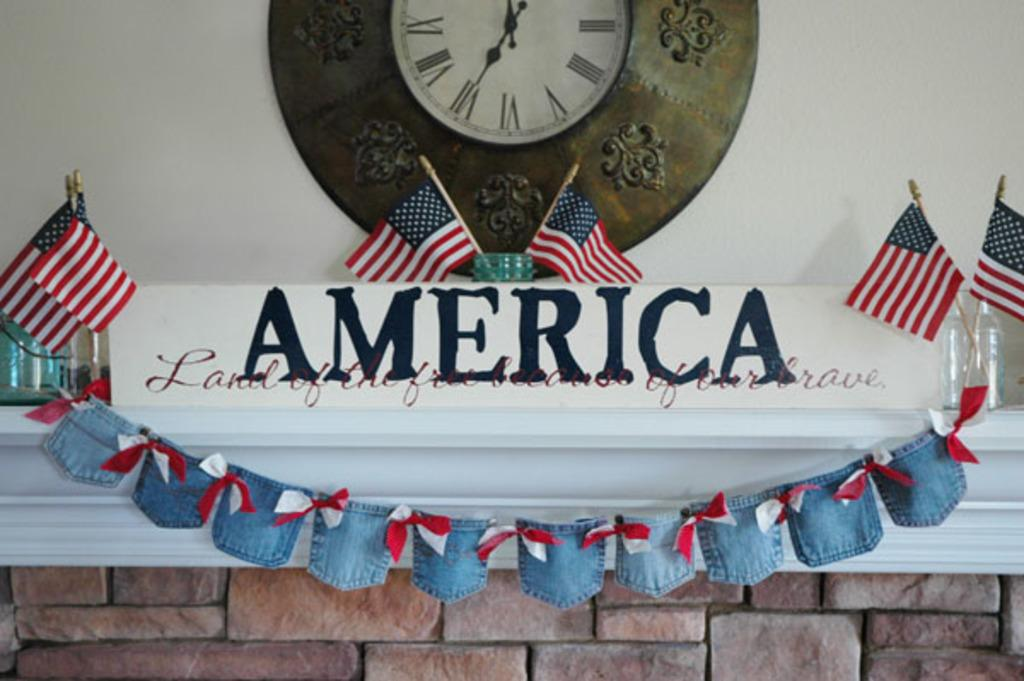<image>
Provide a brief description of the given image. A red, white and blue display on a fireplace mantle celebrates America. 